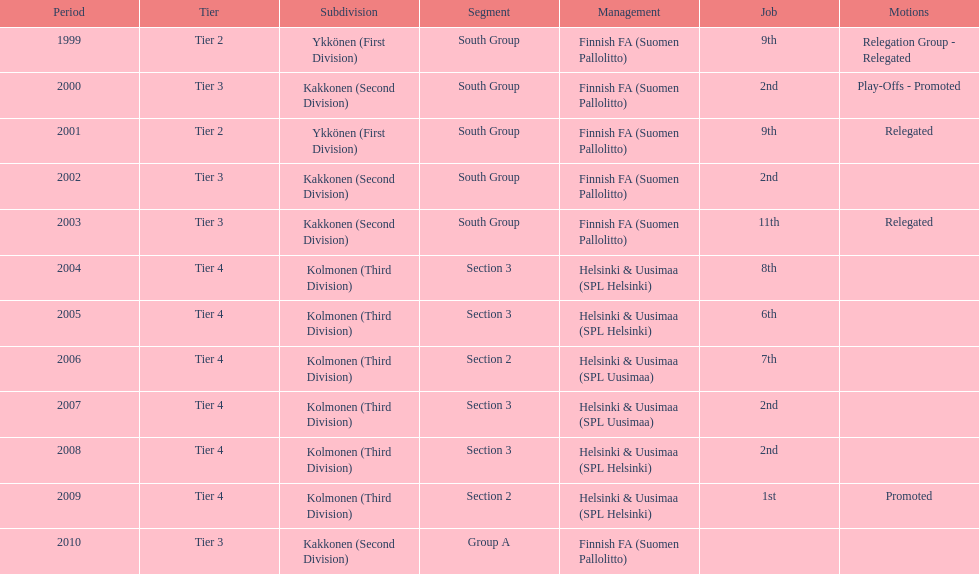Which was the only kolmonen whose movements were promoted? 2009. 